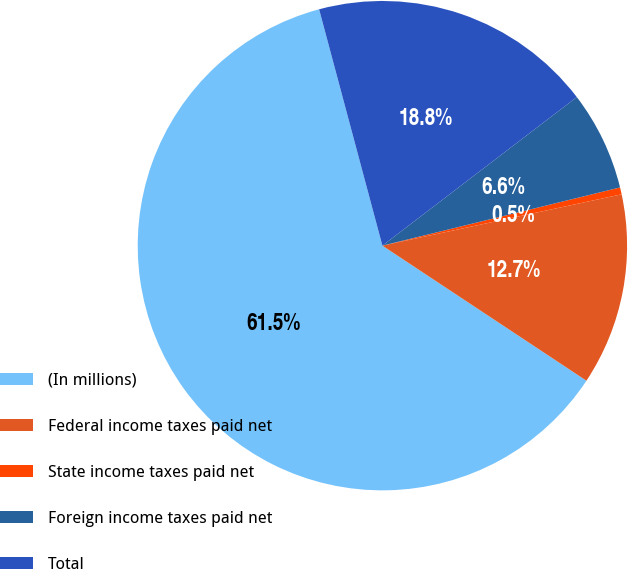Convert chart. <chart><loc_0><loc_0><loc_500><loc_500><pie_chart><fcel>(In millions)<fcel>Federal income taxes paid net<fcel>State income taxes paid net<fcel>Foreign income taxes paid net<fcel>Total<nl><fcel>61.53%<fcel>12.67%<fcel>0.46%<fcel>6.56%<fcel>18.78%<nl></chart> 